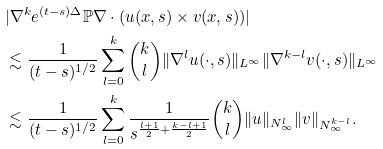Convert formula to latex. <formula><loc_0><loc_0><loc_500><loc_500>& | \nabla ^ { k } e ^ { ( t - s ) \Delta } { \mathbb { P } } \nabla \cdot ( u ( x , s ) \times v ( x , s ) ) | \\ & \lesssim \frac { 1 } { ( t - s ) ^ { 1 / 2 } } \sum _ { l = 0 } ^ { k } \binom { k } { l } \| \nabla ^ { l } u ( \cdot , s ) \| _ { L ^ { \infty } } \| \nabla ^ { k - l } v ( \cdot , s ) \| _ { L ^ { \infty } } \\ & \lesssim \frac { 1 } { ( t - s ) ^ { 1 / 2 } } \sum _ { l = 0 } ^ { k } \frac { 1 } { s ^ { \frac { l + 1 } { 2 } + \frac { k - l + 1 } { 2 } } } \binom { k } { l } \| u \| _ { N ^ { l } _ { \infty } } \| v \| _ { N ^ { k - l } _ { \infty } } .</formula> 